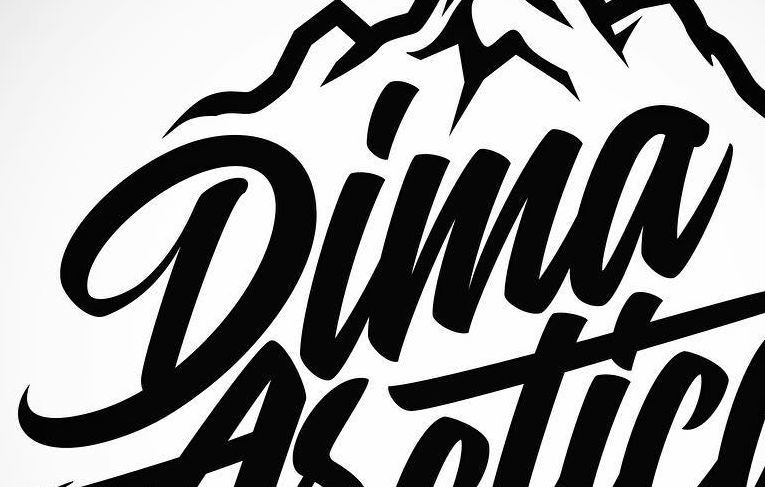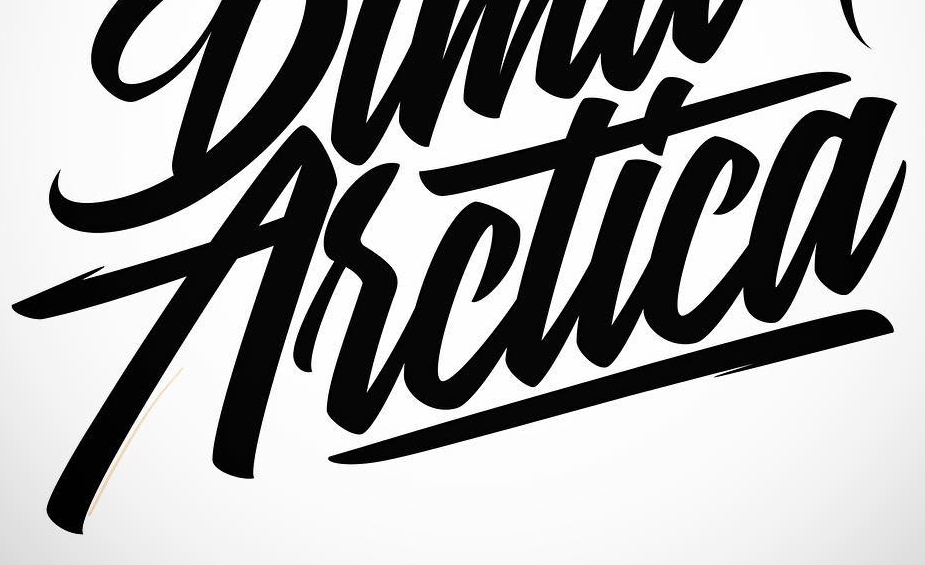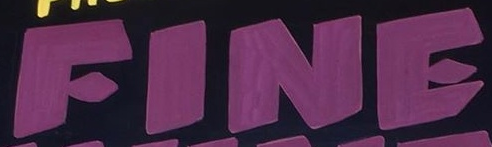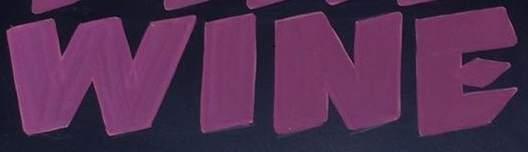What text is displayed in these images sequentially, separated by a semicolon? Dima; Asctica; FINE; WINE 